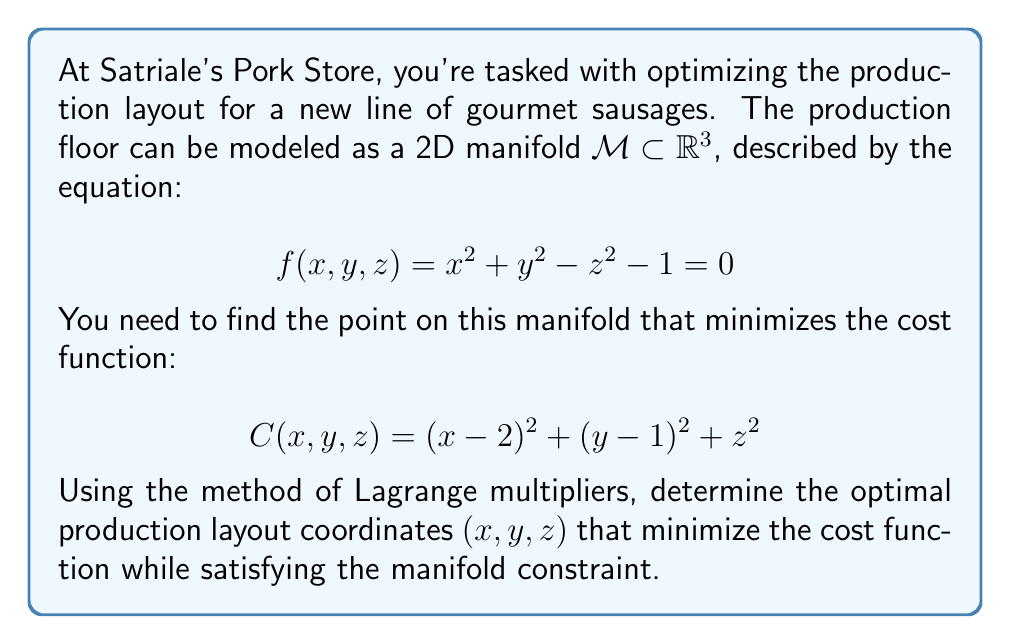Solve this math problem. Let's approach this problem step-by-step, just like Tony Soprano would tackle a complex business decision:

1) We're dealing with a constrained optimization problem on a manifold. The method of Lagrange multipliers is perfect for this situation.

2) Let's define our Lagrangian function:

   $$L(x,y,z,\lambda) = C(x,y,z) - \lambda f(x,y,z)$$
   
   $$L(x,y,z,\lambda) = (x-2)^2 + (y-1)^2 + z^2 - \lambda(x^2 + y^2 - z^2 - 1)$$

3) Now, we need to find the partial derivatives and set them to zero:

   $$\frac{\partial L}{\partial x} = 2(x-2) - 2\lambda x = 0$$
   $$\frac{\partial L}{\partial y} = 2(y-1) - 2\lambda y = 0$$
   $$\frac{\partial L}{\partial z} = 2z + 2\lambda z = 0$$
   $$\frac{\partial L}{\partial \lambda} = -(x^2 + y^2 - z^2 - 1) = 0$$

4) From the third equation:
   $2z(1+\lambda) = 0$, so either $z=0$ or $\lambda = -1$

5) If $z=0$, from the constraint equation:
   $x^2 + y^2 = 1$

6) From the first two equations:
   $x = \frac{2}{1+\lambda}$ and $y = \frac{1}{1+\lambda}$

7) Substituting these into the constraint equation:
   $(\frac{2}{1+\lambda})^2 + (\frac{1}{1+\lambda})^2 = 1$

   $\frac{4+1}{(1+\lambda)^2} = 1$

   $5 = (1+\lambda)^2$

   $\lambda = \sqrt{5} - 1$ or $\lambda = -\sqrt{5} - 1$

8) Since we're minimizing, we choose $\lambda = \sqrt{5} - 1$

9) Substituting back:
   $x = \frac{2}{\sqrt{5}} \approx 0.8944$
   $y = \frac{1}{\sqrt{5}} \approx 0.4472$
   $z = 0$

This solution satisfies all our equations and minimizes the cost function on the given manifold.
Answer: The optimal production layout coordinates are approximately $(0.8944, 0.4472, 0)$. 